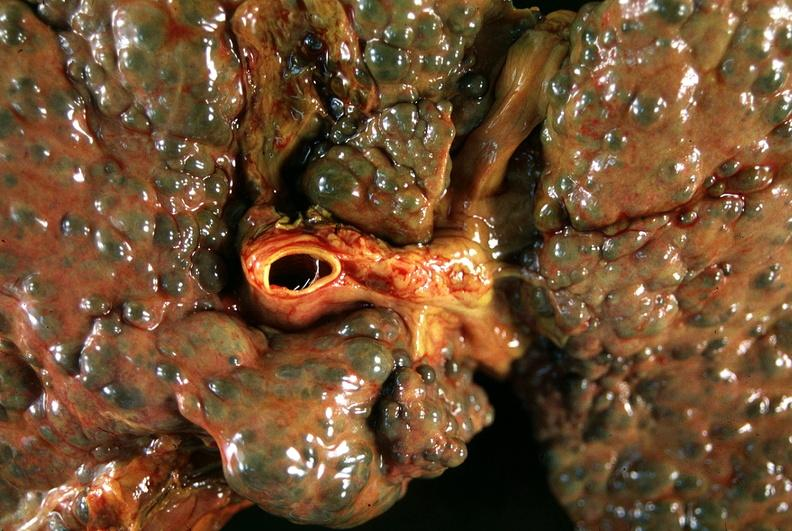does omphalocele show liver, macronodular cirrhosis, hcv - transjugular intrahepatic portocaval shunt tips?
Answer the question using a single word or phrase. No 